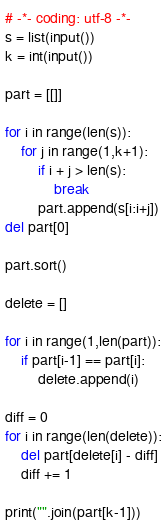Convert code to text. <code><loc_0><loc_0><loc_500><loc_500><_Python_># -*- coding: utf-8 -*-
s = list(input())
k = int(input())

part = [[]]

for i in range(len(s)):
    for j in range(1,k+1):
        if i + j > len(s):
            break
        part.append(s[i:i+j])
del part[0]

part.sort()

delete = []

for i in range(1,len(part)):
    if part[i-1] == part[i]:
        delete.append(i)

diff = 0
for i in range(len(delete)):
    del part[delete[i] - diff]
    diff += 1

print("".join(part[k-1]))
</code> 